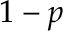<formula> <loc_0><loc_0><loc_500><loc_500>1 - p</formula> 